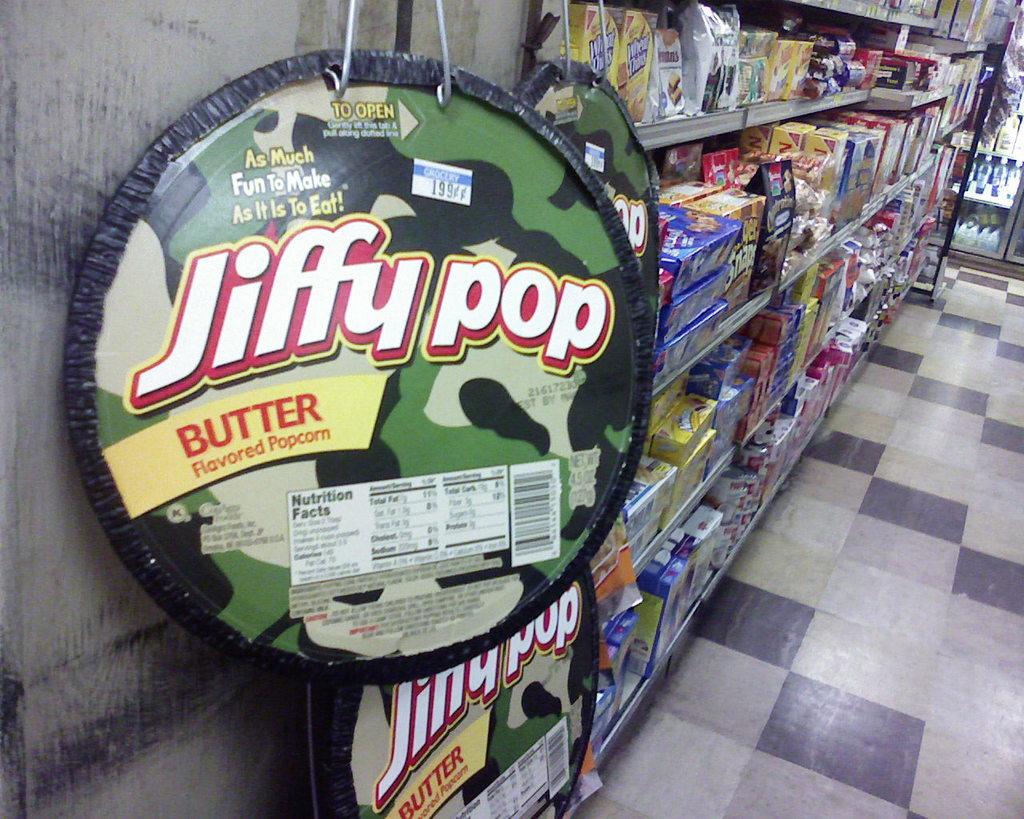What flavor of jiffy pop is featured?
Ensure brevity in your answer.  Butter. What brand of popcorn is advertised?
Provide a short and direct response. Jiffy pop. 